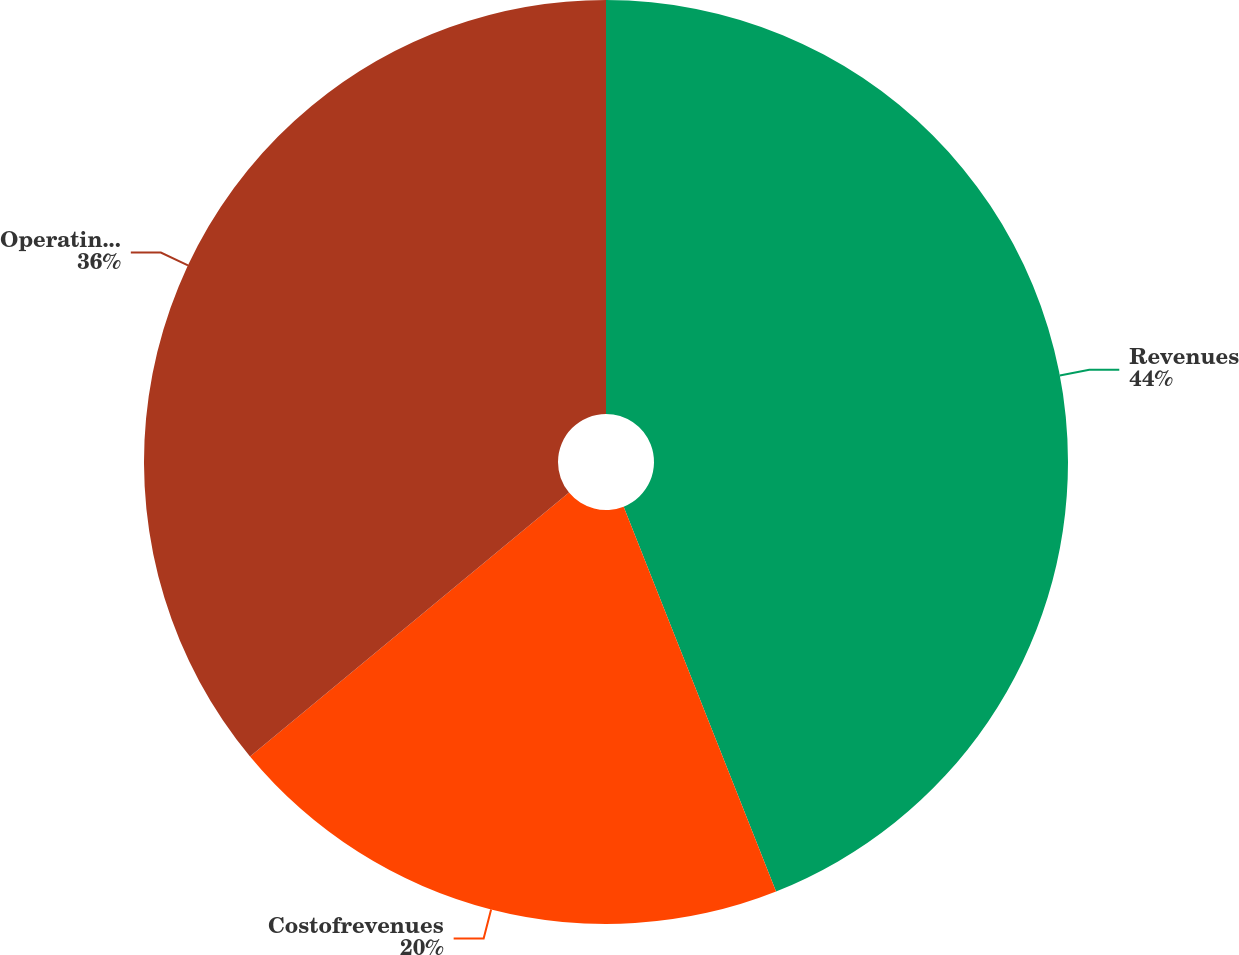Convert chart. <chart><loc_0><loc_0><loc_500><loc_500><pie_chart><fcel>Revenues<fcel>Costofrevenues<fcel>Operating expenses<nl><fcel>44.0%<fcel>20.0%<fcel>36.0%<nl></chart> 